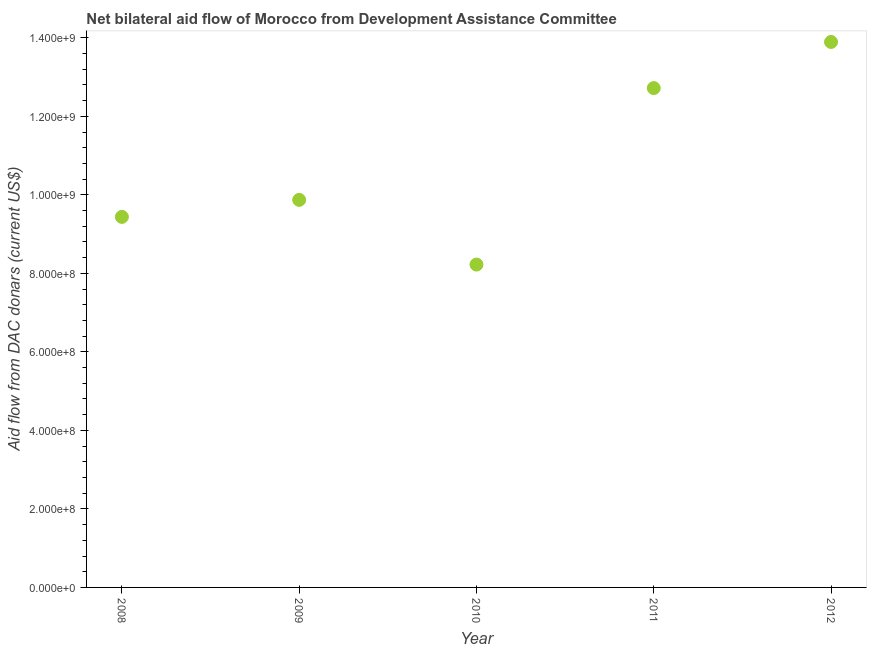What is the net bilateral aid flows from dac donors in 2012?
Offer a very short reply. 1.39e+09. Across all years, what is the maximum net bilateral aid flows from dac donors?
Give a very brief answer. 1.39e+09. Across all years, what is the minimum net bilateral aid flows from dac donors?
Your answer should be very brief. 8.22e+08. What is the sum of the net bilateral aid flows from dac donors?
Keep it short and to the point. 5.41e+09. What is the difference between the net bilateral aid flows from dac donors in 2011 and 2012?
Your answer should be very brief. -1.18e+08. What is the average net bilateral aid flows from dac donors per year?
Offer a terse response. 1.08e+09. What is the median net bilateral aid flows from dac donors?
Your answer should be very brief. 9.87e+08. In how many years, is the net bilateral aid flows from dac donors greater than 560000000 US$?
Your answer should be compact. 5. Do a majority of the years between 2009 and 2008 (inclusive) have net bilateral aid flows from dac donors greater than 280000000 US$?
Make the answer very short. No. What is the ratio of the net bilateral aid flows from dac donors in 2010 to that in 2011?
Your response must be concise. 0.65. Is the net bilateral aid flows from dac donors in 2010 less than that in 2012?
Give a very brief answer. Yes. What is the difference between the highest and the second highest net bilateral aid flows from dac donors?
Offer a very short reply. 1.18e+08. Is the sum of the net bilateral aid flows from dac donors in 2009 and 2011 greater than the maximum net bilateral aid flows from dac donors across all years?
Keep it short and to the point. Yes. What is the difference between the highest and the lowest net bilateral aid flows from dac donors?
Your answer should be very brief. 5.67e+08. In how many years, is the net bilateral aid flows from dac donors greater than the average net bilateral aid flows from dac donors taken over all years?
Offer a terse response. 2. How many years are there in the graph?
Offer a very short reply. 5. What is the title of the graph?
Offer a terse response. Net bilateral aid flow of Morocco from Development Assistance Committee. What is the label or title of the X-axis?
Give a very brief answer. Year. What is the label or title of the Y-axis?
Provide a short and direct response. Aid flow from DAC donars (current US$). What is the Aid flow from DAC donars (current US$) in 2008?
Your response must be concise. 9.44e+08. What is the Aid flow from DAC donars (current US$) in 2009?
Offer a terse response. 9.87e+08. What is the Aid flow from DAC donars (current US$) in 2010?
Offer a very short reply. 8.22e+08. What is the Aid flow from DAC donars (current US$) in 2011?
Offer a very short reply. 1.27e+09. What is the Aid flow from DAC donars (current US$) in 2012?
Keep it short and to the point. 1.39e+09. What is the difference between the Aid flow from DAC donars (current US$) in 2008 and 2009?
Ensure brevity in your answer.  -4.33e+07. What is the difference between the Aid flow from DAC donars (current US$) in 2008 and 2010?
Give a very brief answer. 1.21e+08. What is the difference between the Aid flow from DAC donars (current US$) in 2008 and 2011?
Ensure brevity in your answer.  -3.28e+08. What is the difference between the Aid flow from DAC donars (current US$) in 2008 and 2012?
Provide a short and direct response. -4.46e+08. What is the difference between the Aid flow from DAC donars (current US$) in 2009 and 2010?
Ensure brevity in your answer.  1.65e+08. What is the difference between the Aid flow from DAC donars (current US$) in 2009 and 2011?
Offer a terse response. -2.85e+08. What is the difference between the Aid flow from DAC donars (current US$) in 2009 and 2012?
Keep it short and to the point. -4.02e+08. What is the difference between the Aid flow from DAC donars (current US$) in 2010 and 2011?
Ensure brevity in your answer.  -4.50e+08. What is the difference between the Aid flow from DAC donars (current US$) in 2010 and 2012?
Your response must be concise. -5.67e+08. What is the difference between the Aid flow from DAC donars (current US$) in 2011 and 2012?
Provide a succinct answer. -1.18e+08. What is the ratio of the Aid flow from DAC donars (current US$) in 2008 to that in 2009?
Your answer should be very brief. 0.96. What is the ratio of the Aid flow from DAC donars (current US$) in 2008 to that in 2010?
Offer a terse response. 1.15. What is the ratio of the Aid flow from DAC donars (current US$) in 2008 to that in 2011?
Ensure brevity in your answer.  0.74. What is the ratio of the Aid flow from DAC donars (current US$) in 2008 to that in 2012?
Your answer should be compact. 0.68. What is the ratio of the Aid flow from DAC donars (current US$) in 2009 to that in 2011?
Your answer should be very brief. 0.78. What is the ratio of the Aid flow from DAC donars (current US$) in 2009 to that in 2012?
Your answer should be very brief. 0.71. What is the ratio of the Aid flow from DAC donars (current US$) in 2010 to that in 2011?
Offer a terse response. 0.65. What is the ratio of the Aid flow from DAC donars (current US$) in 2010 to that in 2012?
Your response must be concise. 0.59. What is the ratio of the Aid flow from DAC donars (current US$) in 2011 to that in 2012?
Offer a terse response. 0.92. 